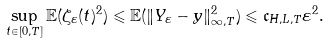Convert formula to latex. <formula><loc_0><loc_0><loc_500><loc_500>\sup _ { t \in [ 0 , T ] } \mathbb { E } ( \zeta _ { \varepsilon } ( t ) ^ { 2 } ) \leqslant \mathbb { E } ( \| Y _ { \varepsilon } - y \| _ { \infty , T } ^ { 2 } ) \leqslant \mathfrak c _ { H , L , T } \varepsilon ^ { 2 } .</formula> 